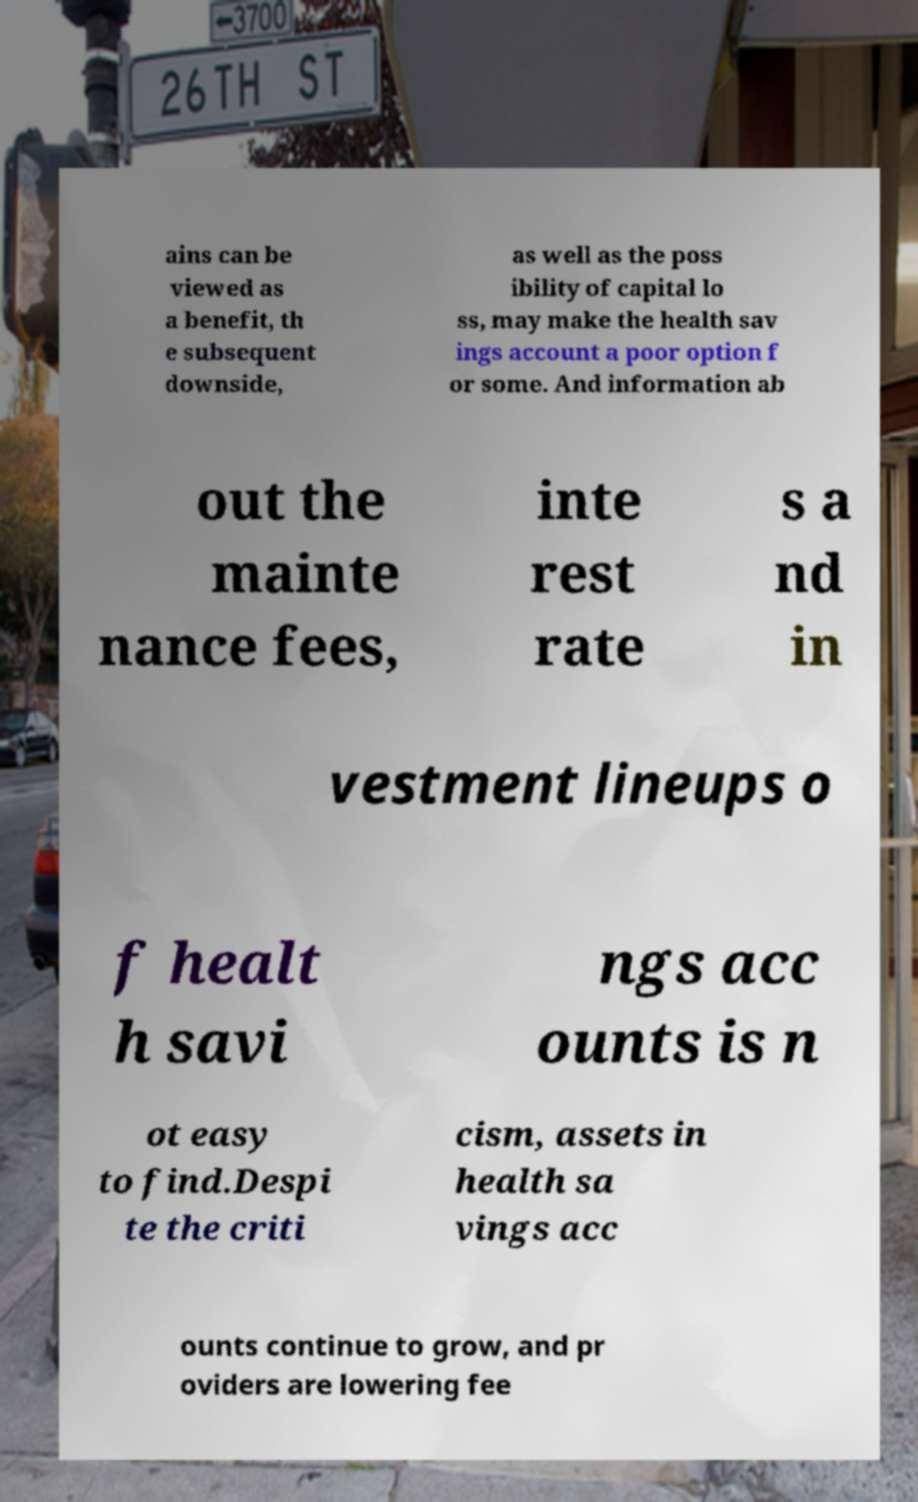What messages or text are displayed in this image? I need them in a readable, typed format. ains can be viewed as a benefit, th e subsequent downside, as well as the poss ibility of capital lo ss, may make the health sav ings account a poor option f or some. And information ab out the mainte nance fees, inte rest rate s a nd in vestment lineups o f healt h savi ngs acc ounts is n ot easy to find.Despi te the criti cism, assets in health sa vings acc ounts continue to grow, and pr oviders are lowering fee 